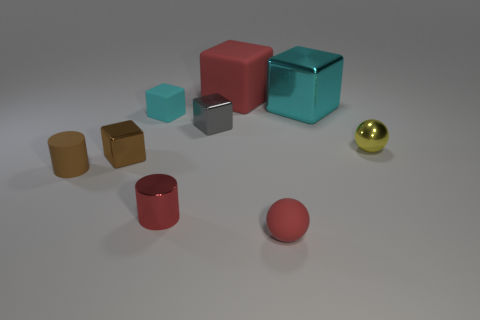Add 1 big cubes. How many objects exist? 10 Subtract all big red rubber blocks. How many blocks are left? 4 Subtract all balls. How many objects are left? 7 Add 5 tiny metallic things. How many tiny metallic things are left? 9 Add 9 large brown matte blocks. How many large brown matte blocks exist? 9 Subtract all red balls. How many balls are left? 1 Subtract 0 green blocks. How many objects are left? 9 Subtract 1 cylinders. How many cylinders are left? 1 Subtract all yellow blocks. Subtract all brown cylinders. How many blocks are left? 5 Subtract all cyan cubes. How many red spheres are left? 1 